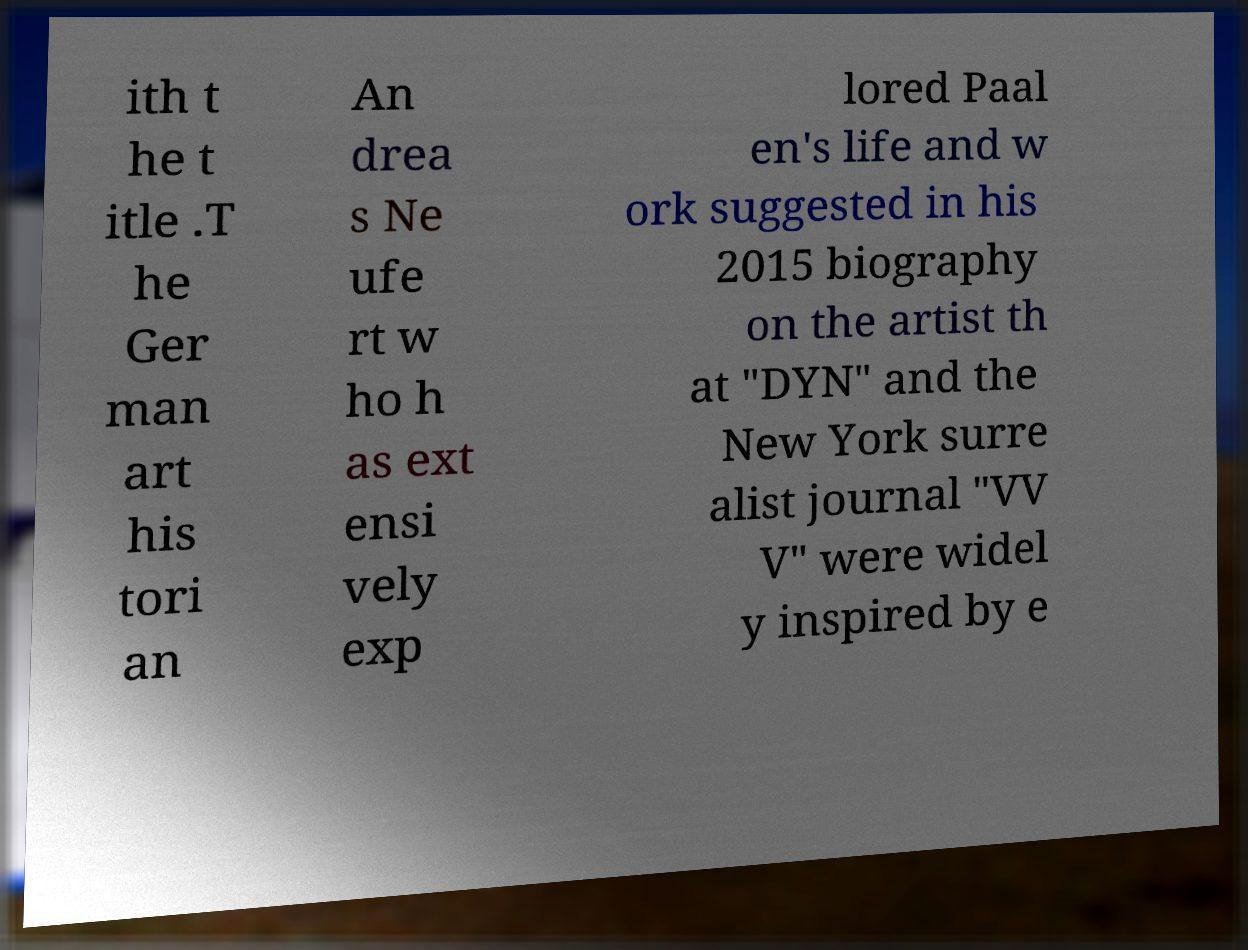Could you extract and type out the text from this image? ith t he t itle .T he Ger man art his tori an An drea s Ne ufe rt w ho h as ext ensi vely exp lored Paal en's life and w ork suggested in his 2015 biography on the artist th at "DYN" and the New York surre alist journal "VV V" were widel y inspired by e 